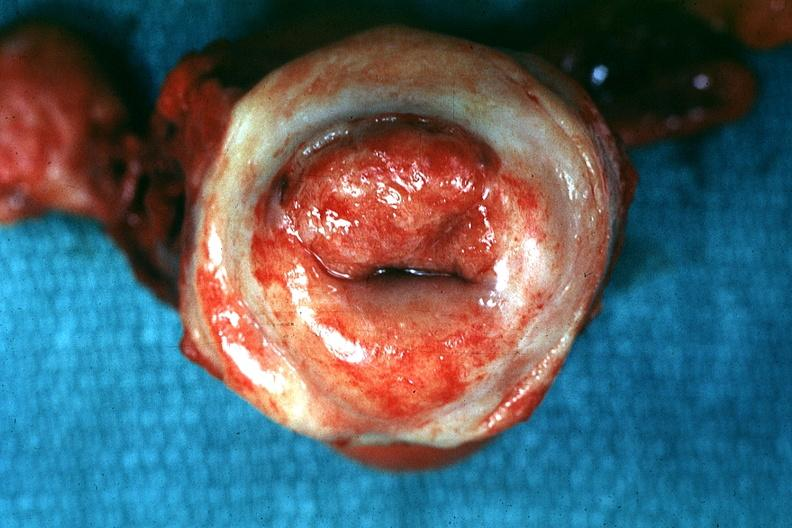what said to be invasive carcinoma?
Answer the question using a single word or phrase. Excellent close-up of thickened and inflamed exocervix 